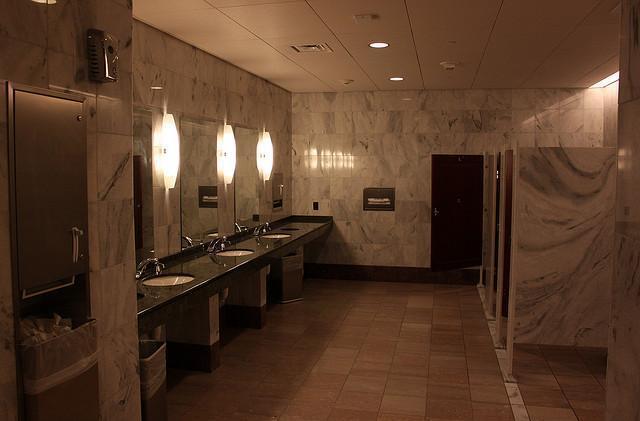How many sinks are in the bathroom?
Give a very brief answer. 3. How many mirrors are there?
Give a very brief answer. 3. How many sinks are in the photo?
Give a very brief answer. 3. 